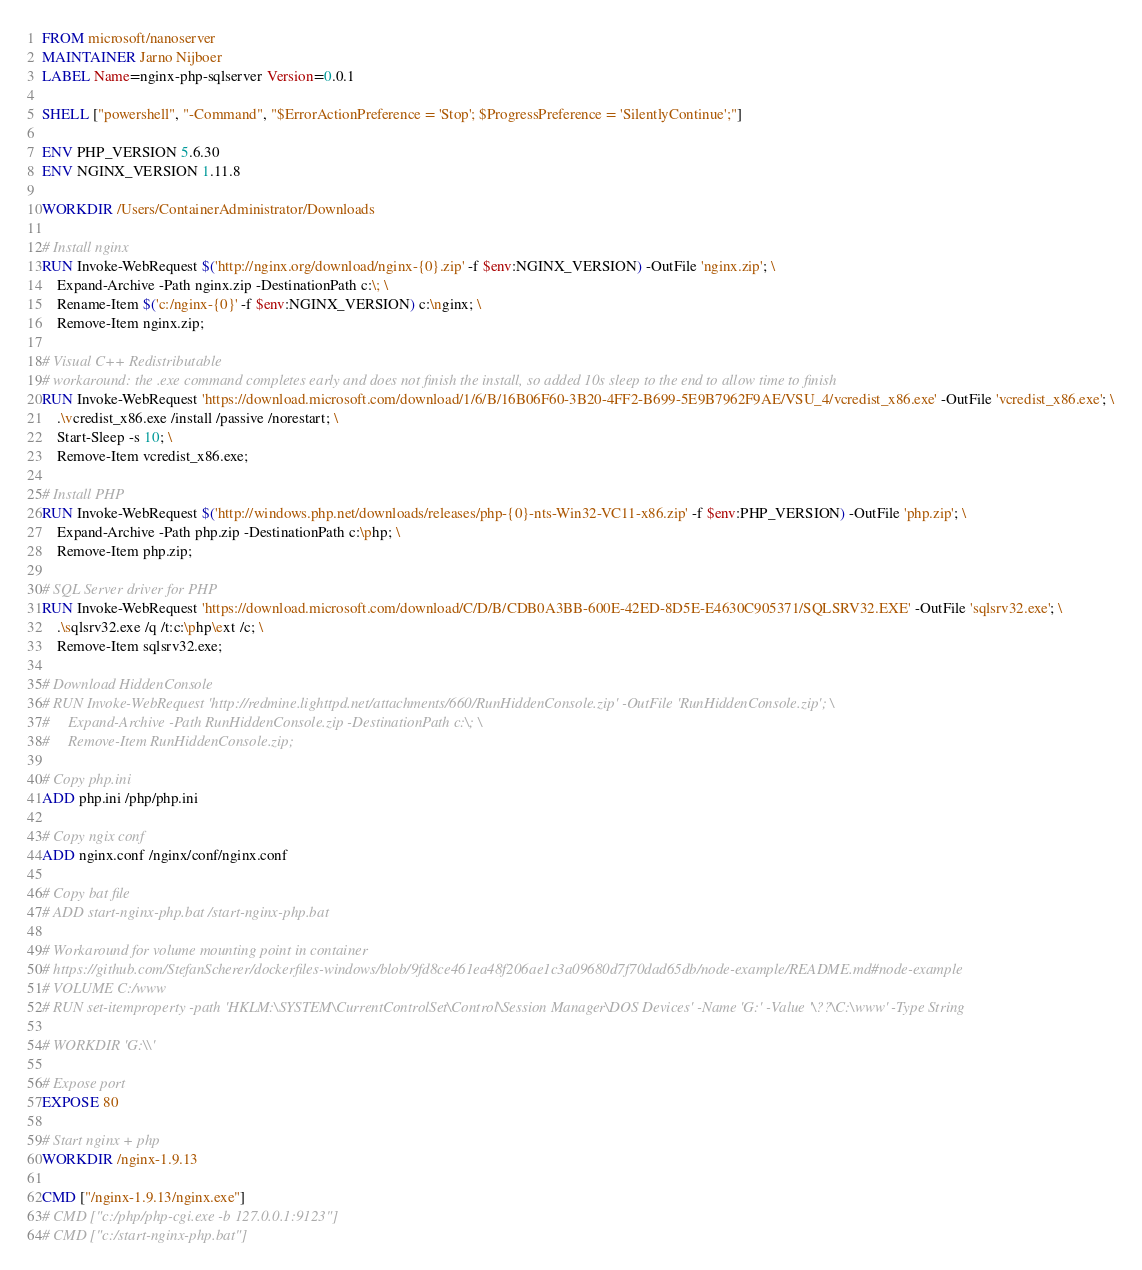Convert code to text. <code><loc_0><loc_0><loc_500><loc_500><_Dockerfile_>FROM microsoft/nanoserver
MAINTAINER Jarno Nijboer
LABEL Name=nginx-php-sqlserver Version=0.0.1

SHELL ["powershell", "-Command", "$ErrorActionPreference = 'Stop'; $ProgressPreference = 'SilentlyContinue';"]

ENV PHP_VERSION 5.6.30
ENV NGINX_VERSION 1.11.8

WORKDIR /Users/ContainerAdministrator/Downloads

# Install nginx
RUN Invoke-WebRequest $('http://nginx.org/download/nginx-{0}.zip' -f $env:NGINX_VERSION) -OutFile 'nginx.zip'; \
    Expand-Archive -Path nginx.zip -DestinationPath c:\; \
    Rename-Item $('c:/nginx-{0}' -f $env:NGINX_VERSION) c:\nginx; \
    Remove-Item nginx.zip;

# Visual C++ Redistributable
# workaround: the .exe command completes early and does not finish the install, so added 10s sleep to the end to allow time to finish
RUN Invoke-WebRequest 'https://download.microsoft.com/download/1/6/B/16B06F60-3B20-4FF2-B699-5E9B7962F9AE/VSU_4/vcredist_x86.exe' -OutFile 'vcredist_x86.exe'; \
    .\vcredist_x86.exe /install /passive /norestart; \
    Start-Sleep -s 10; \
    Remove-Item vcredist_x86.exe;

# Install PHP
RUN Invoke-WebRequest $('http://windows.php.net/downloads/releases/php-{0}-nts-Win32-VC11-x86.zip' -f $env:PHP_VERSION) -OutFile 'php.zip'; \
    Expand-Archive -Path php.zip -DestinationPath c:\php; \
    Remove-Item php.zip;

# SQL Server driver for PHP
RUN Invoke-WebRequest 'https://download.microsoft.com/download/C/D/B/CDB0A3BB-600E-42ED-8D5E-E4630C905371/SQLSRV32.EXE' -OutFile 'sqlsrv32.exe'; \
    .\sqlsrv32.exe /q /t:c:\php\ext /c; \
    Remove-Item sqlsrv32.exe;

# Download HiddenConsole
# RUN Invoke-WebRequest 'http://redmine.lighttpd.net/attachments/660/RunHiddenConsole.zip' -OutFile 'RunHiddenConsole.zip'; \
#     Expand-Archive -Path RunHiddenConsole.zip -DestinationPath c:\; \
#     Remove-Item RunHiddenConsole.zip;

# Copy php.ini
ADD php.ini /php/php.ini

# Copy ngix conf
ADD nginx.conf /nginx/conf/nginx.conf

# Copy bat file
# ADD start-nginx-php.bat /start-nginx-php.bat

# Workaround for volume mounting point in container
# https://github.com/StefanScherer/dockerfiles-windows/blob/9fd8ce461ea48f206ae1c3a09680d7f70dad65db/node-example/README.md#node-example
# VOLUME C:/www
# RUN set-itemproperty -path 'HKLM:\SYSTEM\CurrentControlSet\Control\Session Manager\DOS Devices' -Name 'G:' -Value '\??\C:\www' -Type String

# WORKDIR 'G:\\'

# Expose port
EXPOSE 80

# Start nginx + php
WORKDIR /nginx-1.9.13

CMD ["/nginx-1.9.13/nginx.exe"]
# CMD ["c:/php/php-cgi.exe -b 127.0.0.1:9123"]
# CMD ["c:/start-nginx-php.bat"]
</code> 